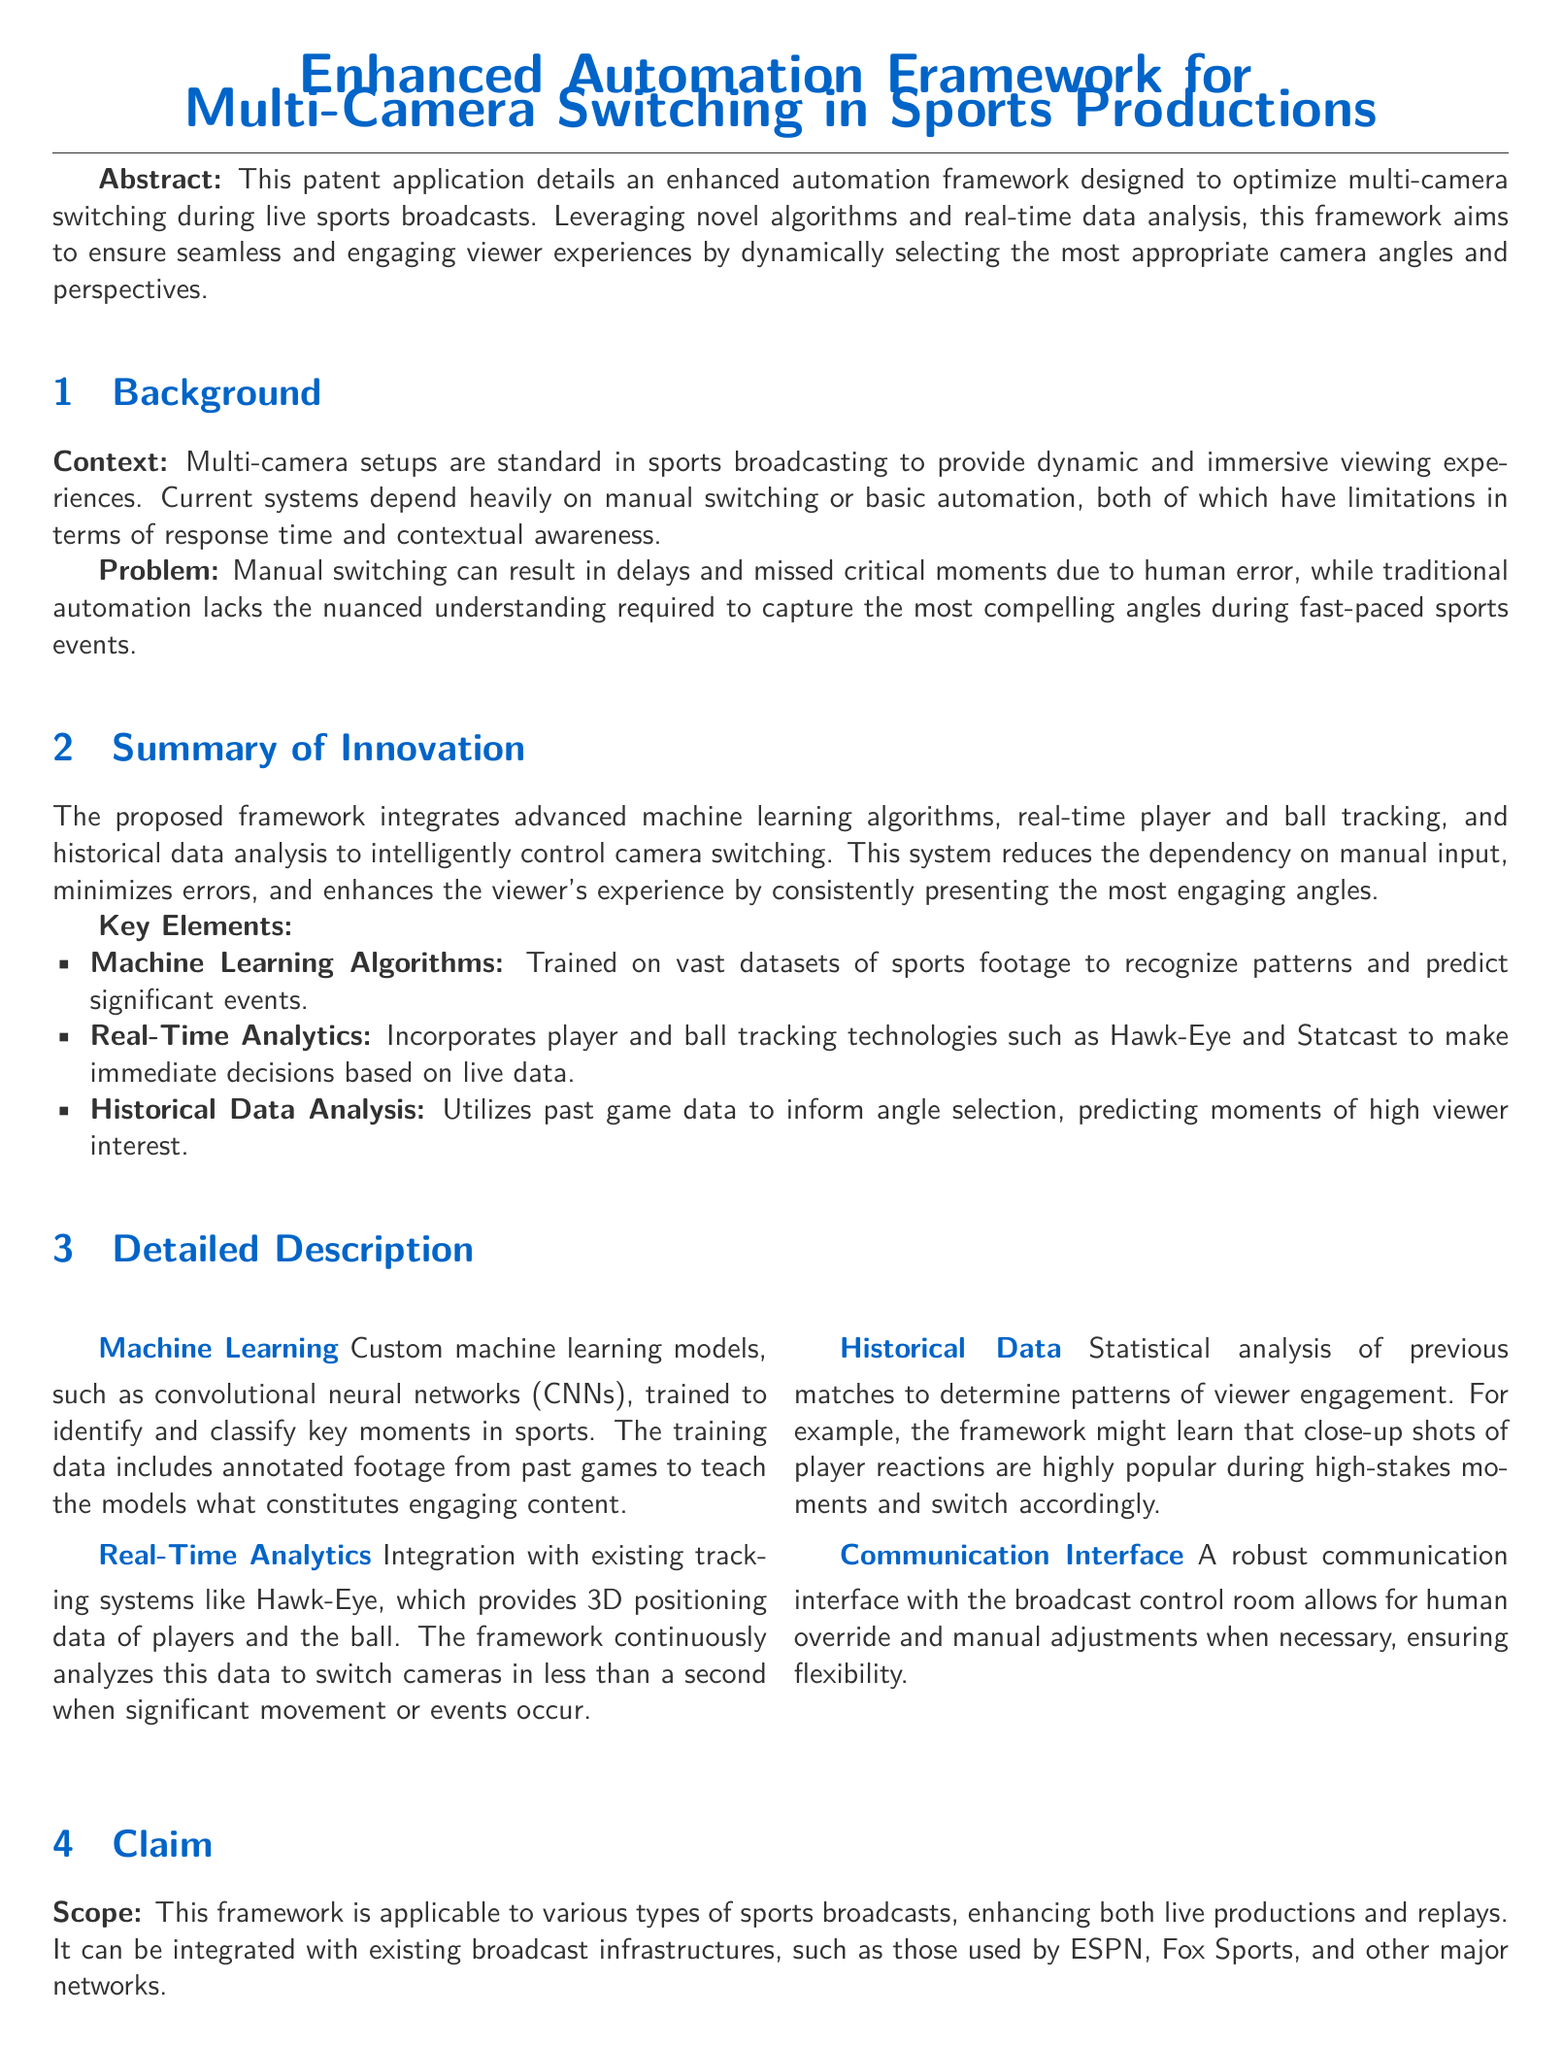What is the title of the patent application? The title of the patent application is the main heading of the document, describing its purpose.
Answer: Enhanced Automation Framework for Multi-Camera Switching in Sports Productions What does the enhanced automation framework aim to optimize? The framework's aim is outlined in the abstract, focusing on improving a specific aspect of sports broadcasting.
Answer: Multi-camera switching What technology provides 3D positioning data of players and the ball? The specific technology mentioned in the detailed description provides this crucial data for the framework's operation.
Answer: Hawk-Eye What is a key feature of the proposed machine learning algorithms? The document explains that the algorithms are trained on specific types of data to identify patterns.
Answer: Recognize patterns How does the framework minimize the dependency on manual input? The elegance of the solution lies in the integration of various elements that reduce human intervention.
Answer: Advanced machine learning algorithms What kind of interface does the framework provide for manual adjustments? The communication aspect is highlighted in the detailed description regarding flexibility in operation.
Answer: Robust communication interface What is one of the unique features of this framework compared to existing systems? The document contrasts the new proposal to previous methods, mentioning a specific aspect that sets it apart.
Answer: Higher degree of automation What does the historical data analysis utilize? The framework's reliance on past performance informs its ability to enhance the viewer's experience, as outlined in the document.
Answer: Previous matches data How quickly can the framework switch cameras? The document specifies an impressive speed of operation for the camera-switching capability.
Answer: Less than a second 